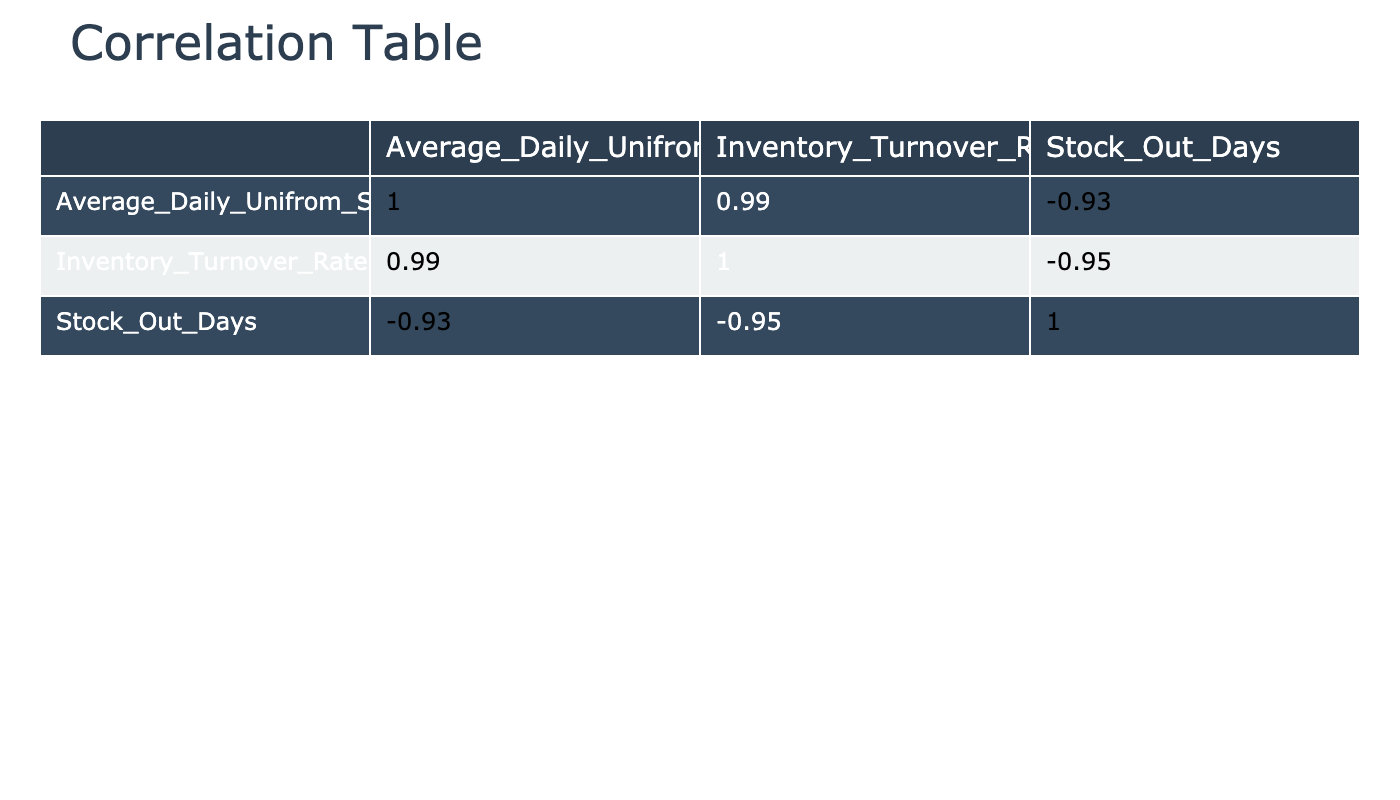What is the correlation coefficient between Average Daily Uniform Sales and Inventory Turnover Rate? From the correlation table, we look at the values in the cell where the row for Average Daily Uniform Sales intersects with the column for Inventory Turnover Rate. The table shows a correlation coefficient of approximately 0.93.
Answer: 0.93 How many Stock Out Days does the Summer season have on average? To determine the average Stock Out Days for the Summer season, we take the total Stock Out Days from the summer months (June, July, and August) which are (2 + 1 + 0 = 3) and divide by 3, resulting in an average of 1.
Answer: 1 Is the Inventory Turnover Rate highest in the Spring season? We need to compare the maximum values of Inventory Turnover Rate across all seasons. In the Spring, the highest rate is 7.0, which is greater than in Summer (6.8), Fall (5.0), and Winter (3.0). Therefore, the statement is true.
Answer: Yes What is the difference in the Average Daily Uniform Sales between Summer and Fall? For Summer, the average daily sales can be calculated using the sales figures for June (250), July (300), and August (350), giving us (250 + 300 + 350) / 3 = 300. For Fall, the average is (200 + 180 + 220) / 3 = 200. Thus, the difference is 300 - 200 = 100.
Answer: 100 Which season has the highest Average Daily Uniform Sales? By inspecting each season's sales, Summer averages 300, Fall averages 200, Winter averages 130, and Spring averages 320. The highest average sales are seen in Spring.
Answer: Spring 